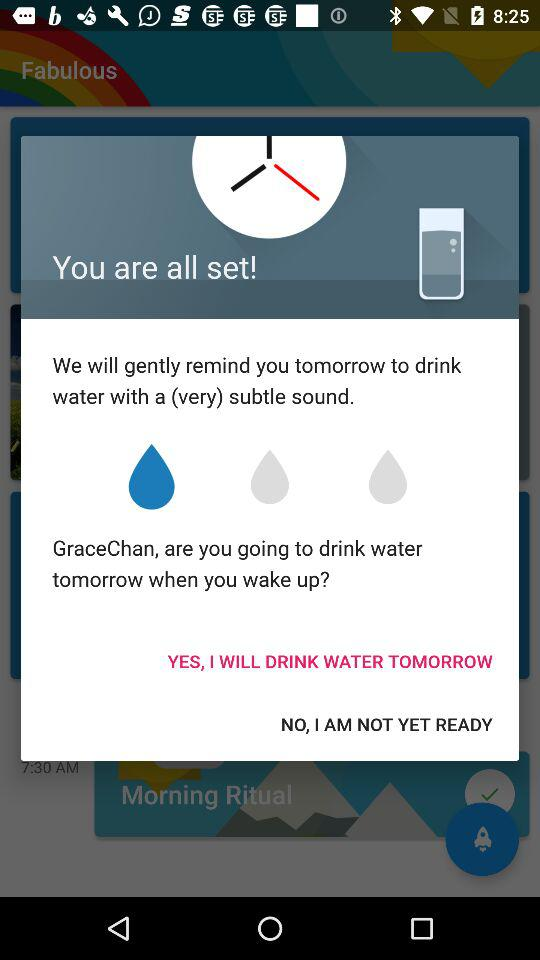How many days will GraceChan be reminded to drink water?
Answer the question using a single word or phrase. 1 